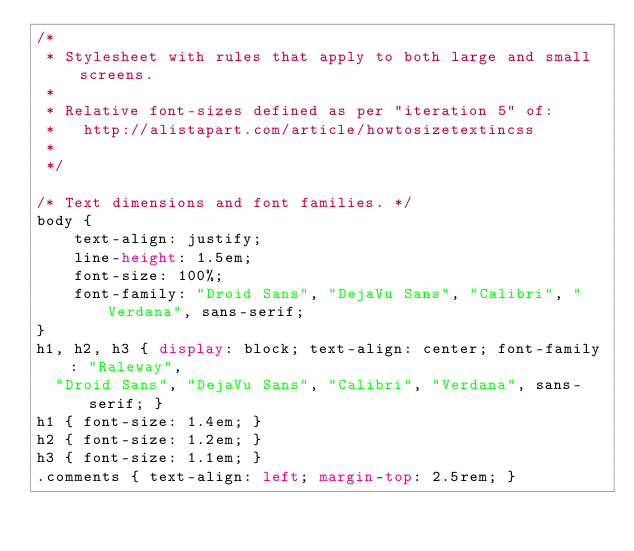<code> <loc_0><loc_0><loc_500><loc_500><_CSS_>/*
 * Stylesheet with rules that apply to both large and small screens.
 *
 * Relative font-sizes defined as per "iteration 5" of:
 *   http://alistapart.com/article/howtosizetextincss
 *
 */

/* Text dimensions and font families. */
body {
    text-align: justify;
    line-height: 1.5em;
    font-size: 100%;
    font-family: "Droid Sans", "DejaVu Sans", "Calibri", "Verdana", sans-serif;
}
h1, h2, h3 { display: block; text-align: center; font-family: "Raleway",
  "Droid Sans", "DejaVu Sans", "Calibri", "Verdana", sans-serif; }
h1 { font-size: 1.4em; }
h2 { font-size: 1.2em; }
h3 { font-size: 1.1em; }
.comments { text-align: left; margin-top: 2.5rem; }</code> 